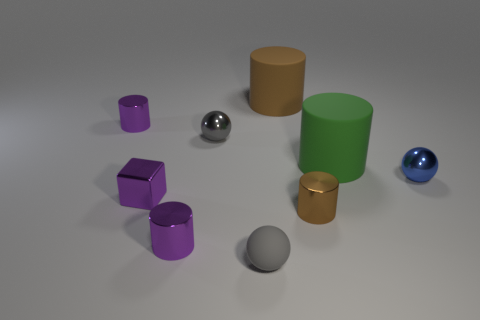Is the material of the tiny block the same as the green cylinder?
Give a very brief answer. No. How many objects are brown cylinders or big green things?
Give a very brief answer. 3. There is a gray thing in front of the brown shiny cylinder; what shape is it?
Your response must be concise. Sphere. What color is the tiny object that is the same material as the big brown object?
Provide a succinct answer. Gray. There is another brown thing that is the same shape as the big brown object; what material is it?
Your answer should be very brief. Metal. There is a gray rubber object; what shape is it?
Your response must be concise. Sphere. The tiny thing that is to the right of the small gray shiny thing and to the left of the large brown cylinder is made of what material?
Keep it short and to the point. Rubber. What shape is the small gray object that is the same material as the tiny blue thing?
Your answer should be very brief. Sphere. The brown cylinder that is made of the same material as the green cylinder is what size?
Offer a terse response. Large. There is a thing that is both behind the blue sphere and to the right of the brown metallic object; what is its shape?
Make the answer very short. Cylinder. 